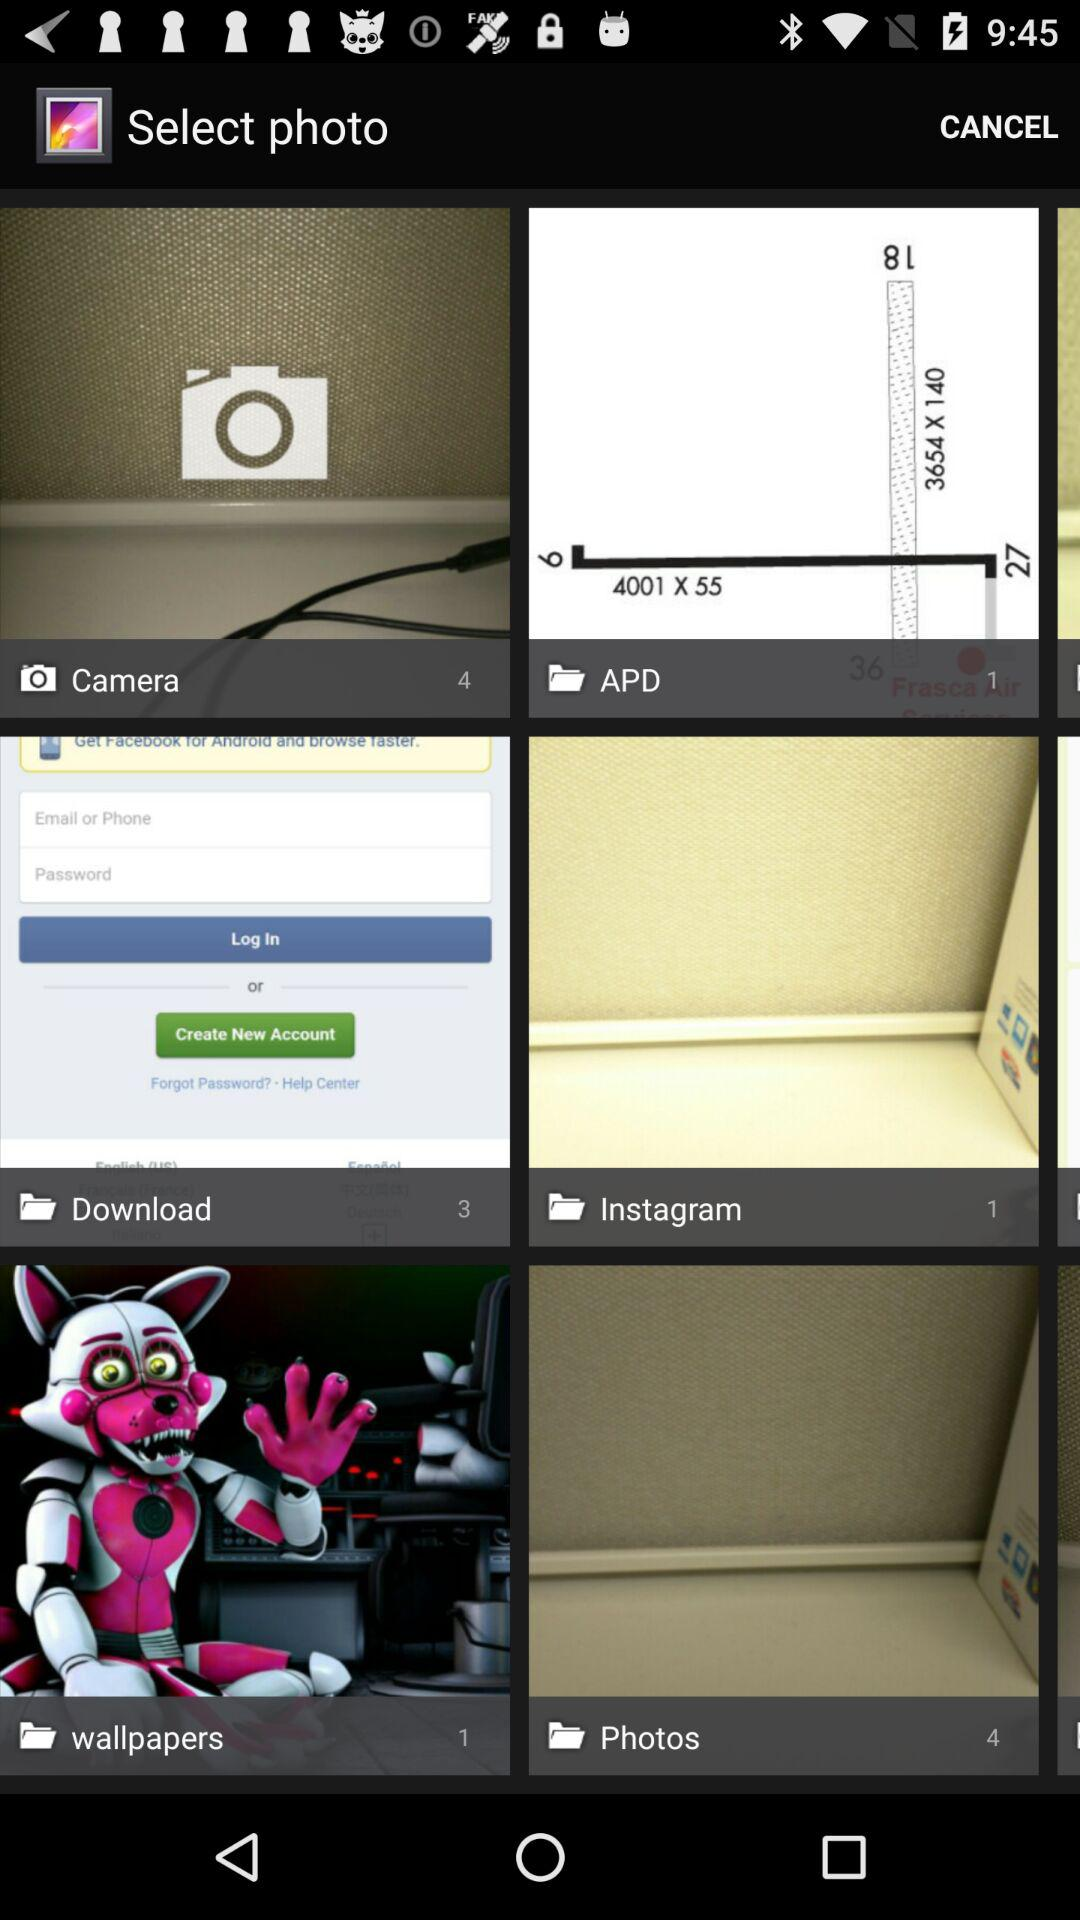How many pics are in the camera folder? The pics are in the camera folder is 4. 